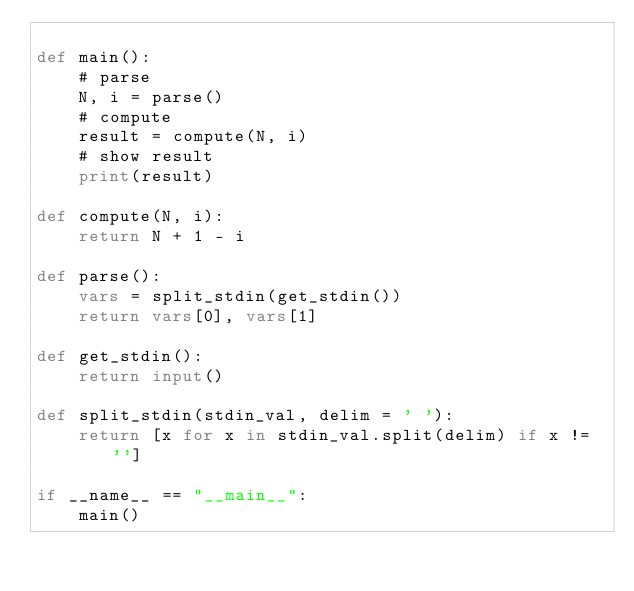Convert code to text. <code><loc_0><loc_0><loc_500><loc_500><_Python_>
def main():
    # parse
    N, i = parse() 
    # compute
    result = compute(N, i)
    # show result
    print(result)

def compute(N, i):
    return N + 1 - i

def parse():
    vars = split_stdin(get_stdin())
    return vars[0], vars[1] 

def get_stdin():
    return input()

def split_stdin(stdin_val, delim = ' '):
    return [x for x in stdin_val.split(delim) if x != '']

if __name__ == "__main__":
    main()</code> 